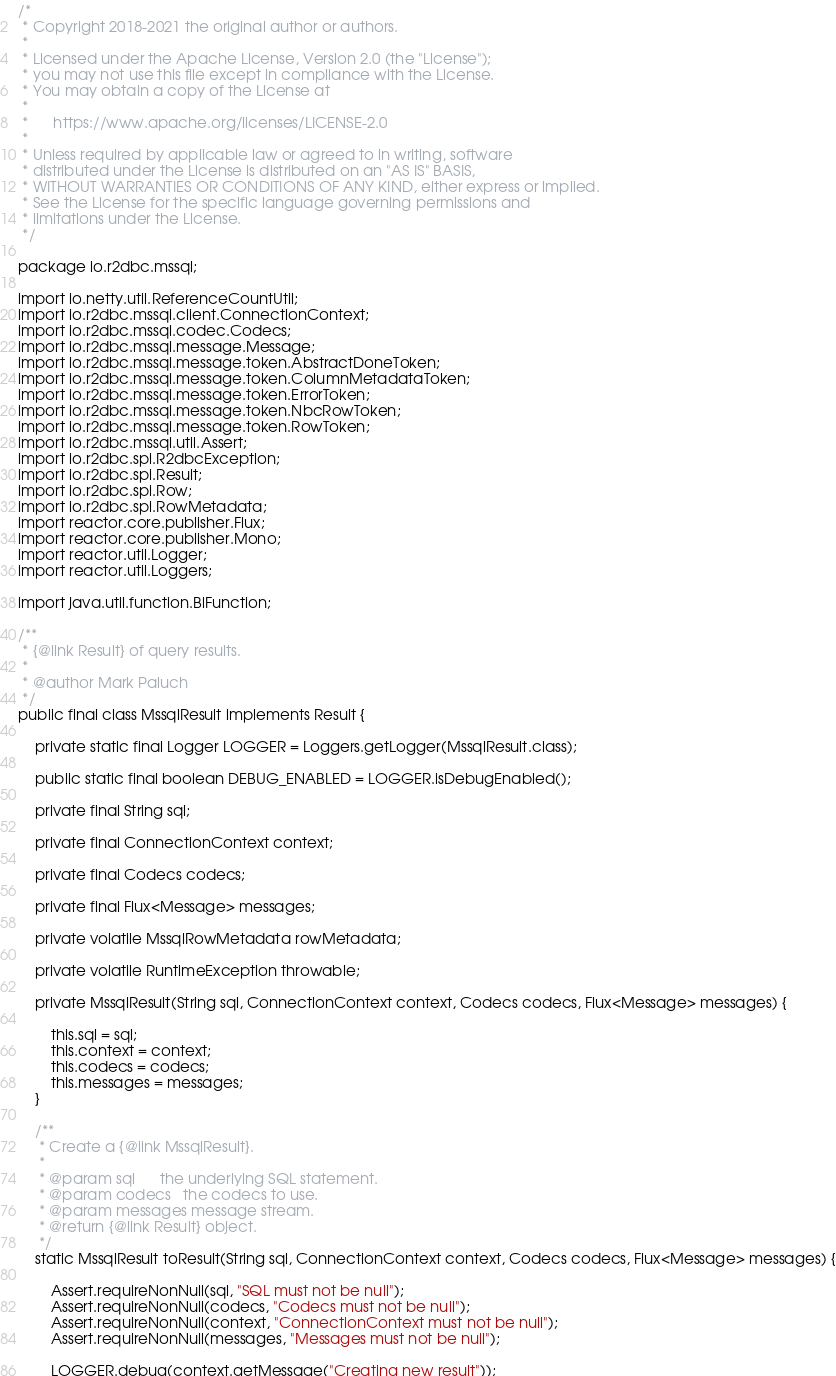Convert code to text. <code><loc_0><loc_0><loc_500><loc_500><_Java_>/*
 * Copyright 2018-2021 the original author or authors.
 *
 * Licensed under the Apache License, Version 2.0 (the "License");
 * you may not use this file except in compliance with the License.
 * You may obtain a copy of the License at
 *
 *      https://www.apache.org/licenses/LICENSE-2.0
 *
 * Unless required by applicable law or agreed to in writing, software
 * distributed under the License is distributed on an "AS IS" BASIS,
 * WITHOUT WARRANTIES OR CONDITIONS OF ANY KIND, either express or implied.
 * See the License for the specific language governing permissions and
 * limitations under the License.
 */

package io.r2dbc.mssql;

import io.netty.util.ReferenceCountUtil;
import io.r2dbc.mssql.client.ConnectionContext;
import io.r2dbc.mssql.codec.Codecs;
import io.r2dbc.mssql.message.Message;
import io.r2dbc.mssql.message.token.AbstractDoneToken;
import io.r2dbc.mssql.message.token.ColumnMetadataToken;
import io.r2dbc.mssql.message.token.ErrorToken;
import io.r2dbc.mssql.message.token.NbcRowToken;
import io.r2dbc.mssql.message.token.RowToken;
import io.r2dbc.mssql.util.Assert;
import io.r2dbc.spi.R2dbcException;
import io.r2dbc.spi.Result;
import io.r2dbc.spi.Row;
import io.r2dbc.spi.RowMetadata;
import reactor.core.publisher.Flux;
import reactor.core.publisher.Mono;
import reactor.util.Logger;
import reactor.util.Loggers;

import java.util.function.BiFunction;

/**
 * {@link Result} of query results.
 *
 * @author Mark Paluch
 */
public final class MssqlResult implements Result {

    private static final Logger LOGGER = Loggers.getLogger(MssqlResult.class);

    public static final boolean DEBUG_ENABLED = LOGGER.isDebugEnabled();

    private final String sql;

    private final ConnectionContext context;

    private final Codecs codecs;

    private final Flux<Message> messages;

    private volatile MssqlRowMetadata rowMetadata;

    private volatile RuntimeException throwable;

    private MssqlResult(String sql, ConnectionContext context, Codecs codecs, Flux<Message> messages) {

        this.sql = sql;
        this.context = context;
        this.codecs = codecs;
        this.messages = messages;
    }

    /**
     * Create a {@link MssqlResult}.
     *
     * @param sql      the underlying SQL statement.
     * @param codecs   the codecs to use.
     * @param messages message stream.
     * @return {@link Result} object.
     */
    static MssqlResult toResult(String sql, ConnectionContext context, Codecs codecs, Flux<Message> messages) {

        Assert.requireNonNull(sql, "SQL must not be null");
        Assert.requireNonNull(codecs, "Codecs must not be null");
        Assert.requireNonNull(context, "ConnectionContext must not be null");
        Assert.requireNonNull(messages, "Messages must not be null");

        LOGGER.debug(context.getMessage("Creating new result"));
</code> 